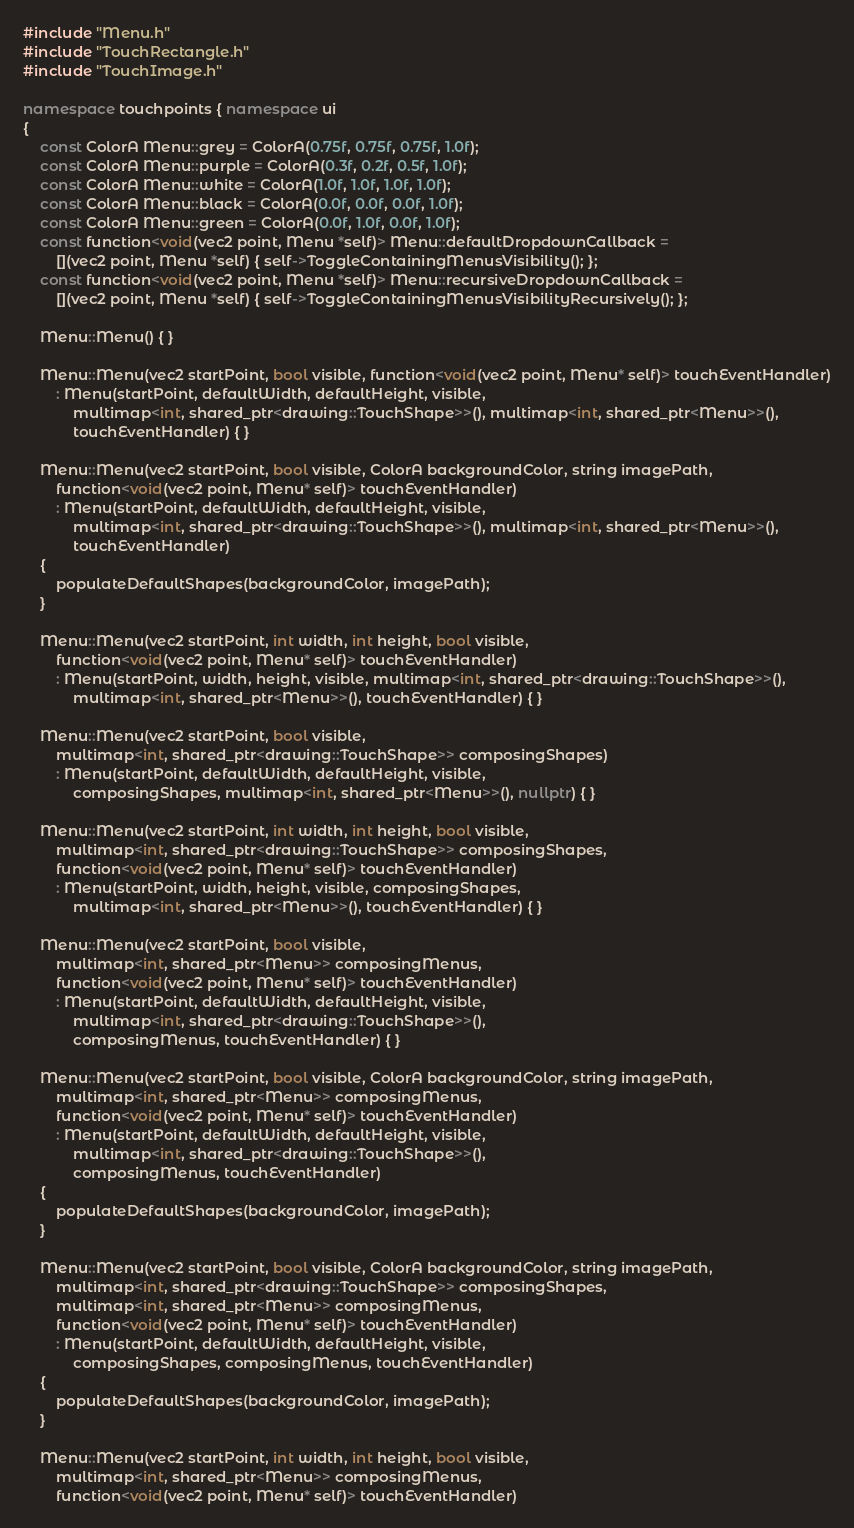<code> <loc_0><loc_0><loc_500><loc_500><_C++_>#include "Menu.h"
#include "TouchRectangle.h"
#include "TouchImage.h"

namespace touchpoints { namespace ui
{
	const ColorA Menu::grey = ColorA(0.75f, 0.75f, 0.75f, 1.0f);
	const ColorA Menu::purple = ColorA(0.3f, 0.2f, 0.5f, 1.0f);
	const ColorA Menu::white = ColorA(1.0f, 1.0f, 1.0f, 1.0f);
	const ColorA Menu::black = ColorA(0.0f, 0.0f, 0.0f, 1.0f);
	const ColorA Menu::green = ColorA(0.0f, 1.0f, 0.0f, 1.0f);
	const function<void(vec2 point, Menu *self)> Menu::defaultDropdownCallback =
		[](vec2 point, Menu *self) { self->ToggleContainingMenusVisibility(); };
	const function<void(vec2 point, Menu *self)> Menu::recursiveDropdownCallback =
		[](vec2 point, Menu *self) { self->ToggleContainingMenusVisibilityRecursively(); };

	Menu::Menu() { }

	Menu::Menu(vec2 startPoint, bool visible, function<void(vec2 point, Menu* self)> touchEventHandler)
		: Menu(startPoint, defaultWidth, defaultHeight, visible,
			multimap<int, shared_ptr<drawing::TouchShape>>(), multimap<int, shared_ptr<Menu>>(),
			touchEventHandler) { }

	Menu::Menu(vec2 startPoint, bool visible, ColorA backgroundColor, string imagePath,
		function<void(vec2 point, Menu* self)> touchEventHandler)
		: Menu(startPoint, defaultWidth, defaultHeight, visible,
			multimap<int, shared_ptr<drawing::TouchShape>>(), multimap<int, shared_ptr<Menu>>(),
			touchEventHandler)
	{
		populateDefaultShapes(backgroundColor, imagePath);
	}

	Menu::Menu(vec2 startPoint, int width, int height, bool visible,
		function<void(vec2 point, Menu* self)> touchEventHandler)
		: Menu(startPoint, width, height, visible, multimap<int, shared_ptr<drawing::TouchShape>>(), 
			multimap<int, shared_ptr<Menu>>(), touchEventHandler) { }

	Menu::Menu(vec2 startPoint, bool visible,
		multimap<int, shared_ptr<drawing::TouchShape>> composingShapes)
		: Menu(startPoint, defaultWidth, defaultHeight, visible,
			composingShapes, multimap<int, shared_ptr<Menu>>(), nullptr) { }

	Menu::Menu(vec2 startPoint, int width, int height, bool visible,
		multimap<int, shared_ptr<drawing::TouchShape>> composingShapes,
		function<void(vec2 point, Menu* self)> touchEventHandler)
		: Menu(startPoint, width, height, visible, composingShapes,
			multimap<int, shared_ptr<Menu>>(), touchEventHandler) { }

	Menu::Menu(vec2 startPoint, bool visible,
		multimap<int, shared_ptr<Menu>> composingMenus,
		function<void(vec2 point, Menu* self)> touchEventHandler)
		: Menu(startPoint, defaultWidth, defaultHeight, visible,
			multimap<int, shared_ptr<drawing::TouchShape>>(),
			composingMenus, touchEventHandler) { }

	Menu::Menu(vec2 startPoint, bool visible, ColorA backgroundColor, string imagePath,
		multimap<int, shared_ptr<Menu>> composingMenus,
		function<void(vec2 point, Menu* self)> touchEventHandler)
		: Menu(startPoint, defaultWidth, defaultHeight, visible,
			multimap<int, shared_ptr<drawing::TouchShape>>(),
			composingMenus, touchEventHandler)
	{
		populateDefaultShapes(backgroundColor, imagePath);
	}

	Menu::Menu(vec2 startPoint, bool visible, ColorA backgroundColor, string imagePath,
		multimap<int, shared_ptr<drawing::TouchShape>> composingShapes,
		multimap<int, shared_ptr<Menu>> composingMenus,
		function<void(vec2 point, Menu* self)> touchEventHandler)
		: Menu(startPoint, defaultWidth, defaultHeight, visible,
			composingShapes, composingMenus, touchEventHandler)
	{
		populateDefaultShapes(backgroundColor, imagePath);
	}

	Menu::Menu(vec2 startPoint, int width, int height, bool visible,
		multimap<int, shared_ptr<Menu>> composingMenus,
		function<void(vec2 point, Menu* self)> touchEventHandler)</code> 